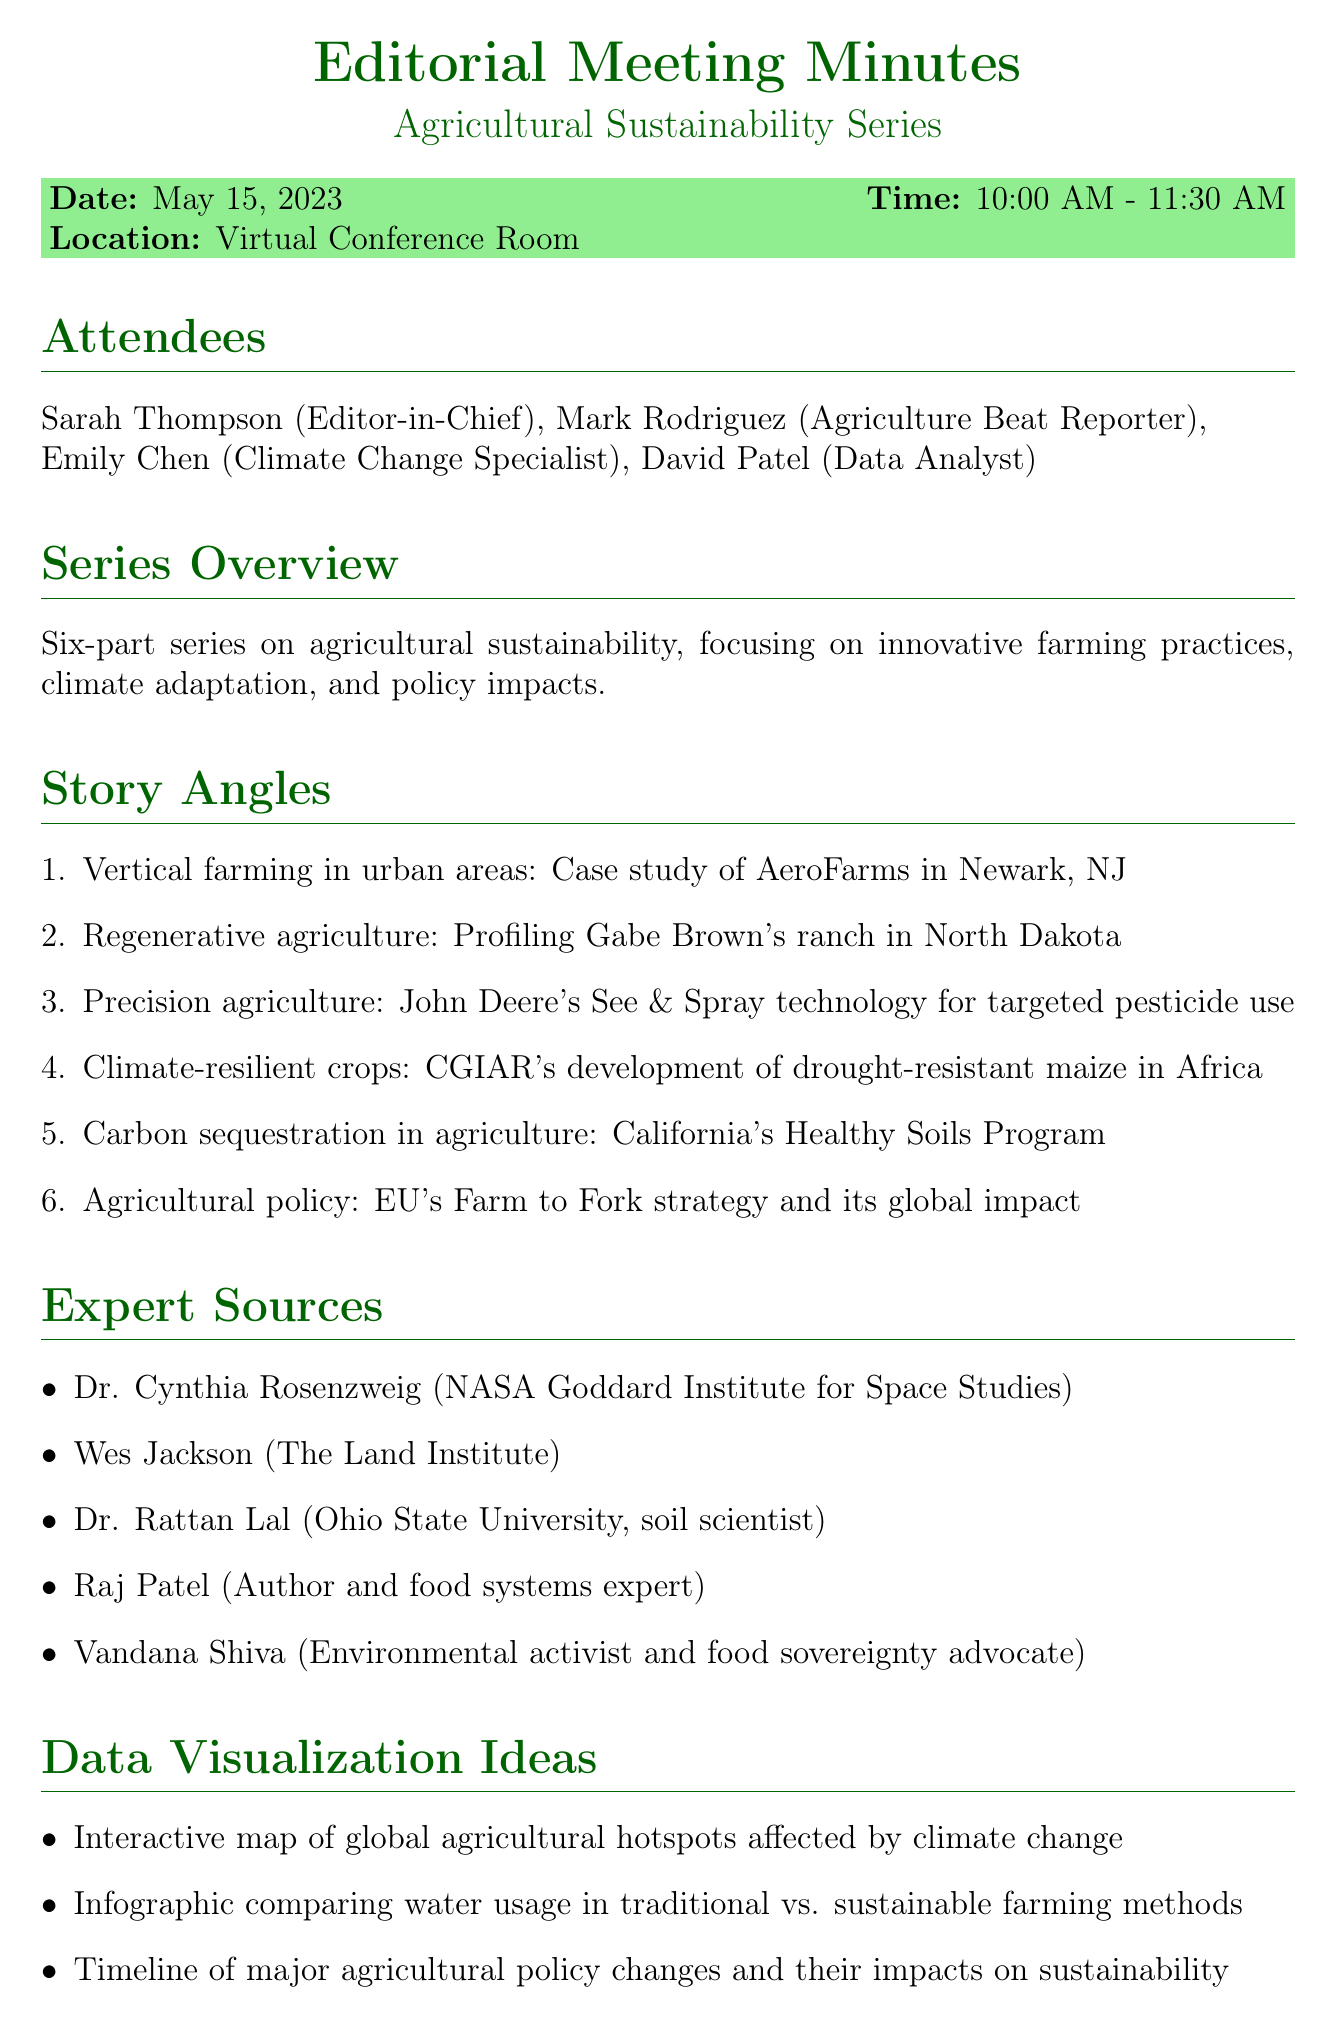What is the date of the meeting? The date of the meeting is mentioned as May 15, 2023.
Answer: May 15, 2023 Who is the Agriculture Beat Reporter? The document lists Mark Rodriguez as the Agriculture Beat Reporter among the attendees.
Answer: Mark Rodriguez How many story angles are outlined in the meeting? The number of story angles detailed in the document is counted and found to be six.
Answer: Six What is one of the expert sources listed? The document provides a list of expert sources, including Dr. Cynthia Rosenzweig as one example.
Answer: Dr. Cynthia Rosenzweig What specific theme does the series focus on? The overview of the series explicitly states that it focuses on agricultural sustainability.
Answer: Agricultural sustainability Which story angle includes a case study of a company? The story angle about Vertical farming specifically mentions a case study of AeroFarms.
Answer: AeroFarms What visualization idea is related to climate change? The document includes an idea for an interactive map of global agricultural hotspots affected by climate change.
Answer: Interactive map What action is planned regarding deadlines? The next steps include setting deadlines for draft submissions and editorial reviews.
Answer: Set deadlines 